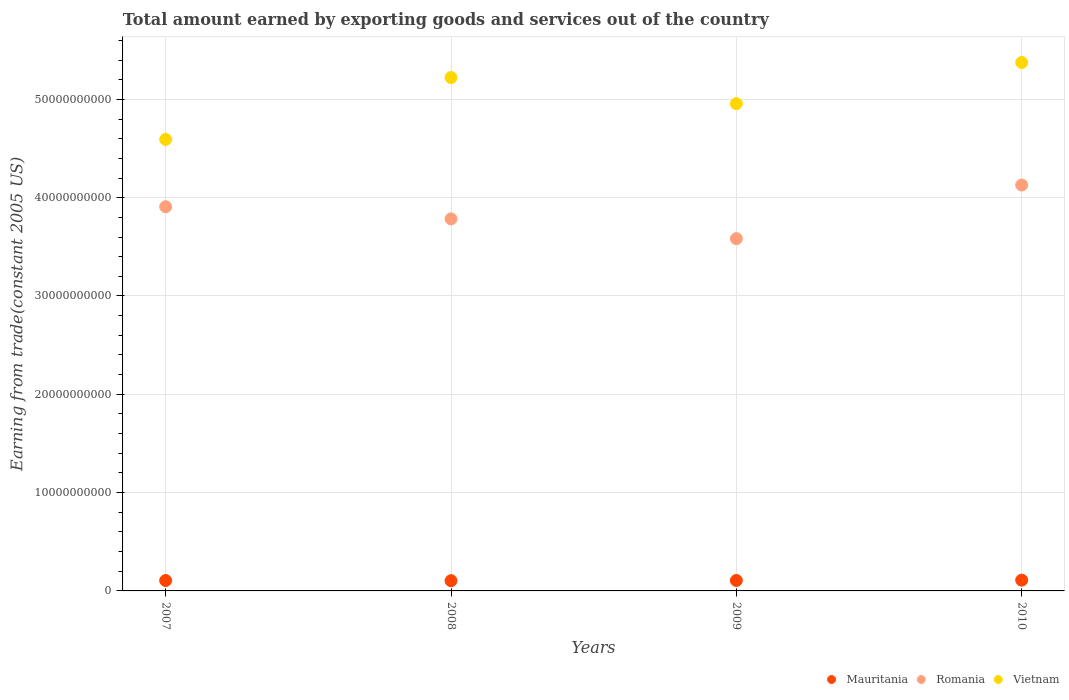Is the number of dotlines equal to the number of legend labels?
Your response must be concise. Yes. What is the total amount earned by exporting goods and services in Mauritania in 2008?
Provide a succinct answer. 1.04e+09. Across all years, what is the maximum total amount earned by exporting goods and services in Mauritania?
Your answer should be very brief. 1.10e+09. Across all years, what is the minimum total amount earned by exporting goods and services in Vietnam?
Your answer should be compact. 4.59e+1. In which year was the total amount earned by exporting goods and services in Mauritania maximum?
Offer a very short reply. 2010. What is the total total amount earned by exporting goods and services in Vietnam in the graph?
Give a very brief answer. 2.01e+11. What is the difference between the total amount earned by exporting goods and services in Mauritania in 2009 and that in 2010?
Your response must be concise. -3.44e+07. What is the difference between the total amount earned by exporting goods and services in Vietnam in 2009 and the total amount earned by exporting goods and services in Mauritania in 2007?
Give a very brief answer. 4.85e+1. What is the average total amount earned by exporting goods and services in Romania per year?
Your response must be concise. 3.85e+1. In the year 2007, what is the difference between the total amount earned by exporting goods and services in Mauritania and total amount earned by exporting goods and services in Vietnam?
Provide a short and direct response. -4.49e+1. What is the ratio of the total amount earned by exporting goods and services in Vietnam in 2007 to that in 2010?
Make the answer very short. 0.85. Is the difference between the total amount earned by exporting goods and services in Mauritania in 2008 and 2009 greater than the difference between the total amount earned by exporting goods and services in Vietnam in 2008 and 2009?
Provide a short and direct response. No. What is the difference between the highest and the second highest total amount earned by exporting goods and services in Mauritania?
Your answer should be very brief. 3.44e+07. What is the difference between the highest and the lowest total amount earned by exporting goods and services in Mauritania?
Keep it short and to the point. 5.71e+07. Is the sum of the total amount earned by exporting goods and services in Mauritania in 2008 and 2010 greater than the maximum total amount earned by exporting goods and services in Romania across all years?
Your response must be concise. No. Does the total amount earned by exporting goods and services in Romania monotonically increase over the years?
Ensure brevity in your answer.  No. Is the total amount earned by exporting goods and services in Vietnam strictly greater than the total amount earned by exporting goods and services in Mauritania over the years?
Provide a succinct answer. Yes. How many years are there in the graph?
Provide a short and direct response. 4. Where does the legend appear in the graph?
Your answer should be compact. Bottom right. How many legend labels are there?
Give a very brief answer. 3. What is the title of the graph?
Offer a terse response. Total amount earned by exporting goods and services out of the country. Does "Middle East & North Africa (all income levels)" appear as one of the legend labels in the graph?
Your response must be concise. No. What is the label or title of the X-axis?
Make the answer very short. Years. What is the label or title of the Y-axis?
Provide a succinct answer. Earning from trade(constant 2005 US). What is the Earning from trade(constant 2005 US) in Mauritania in 2007?
Ensure brevity in your answer.  1.06e+09. What is the Earning from trade(constant 2005 US) in Romania in 2007?
Your answer should be compact. 3.91e+1. What is the Earning from trade(constant 2005 US) in Vietnam in 2007?
Provide a short and direct response. 4.59e+1. What is the Earning from trade(constant 2005 US) in Mauritania in 2008?
Provide a short and direct response. 1.04e+09. What is the Earning from trade(constant 2005 US) of Romania in 2008?
Offer a terse response. 3.78e+1. What is the Earning from trade(constant 2005 US) of Vietnam in 2008?
Make the answer very short. 5.22e+1. What is the Earning from trade(constant 2005 US) of Mauritania in 2009?
Provide a short and direct response. 1.06e+09. What is the Earning from trade(constant 2005 US) in Romania in 2009?
Keep it short and to the point. 3.58e+1. What is the Earning from trade(constant 2005 US) in Vietnam in 2009?
Ensure brevity in your answer.  4.96e+1. What is the Earning from trade(constant 2005 US) of Mauritania in 2010?
Ensure brevity in your answer.  1.10e+09. What is the Earning from trade(constant 2005 US) of Romania in 2010?
Provide a short and direct response. 4.13e+1. What is the Earning from trade(constant 2005 US) of Vietnam in 2010?
Your answer should be compact. 5.38e+1. Across all years, what is the maximum Earning from trade(constant 2005 US) of Mauritania?
Keep it short and to the point. 1.10e+09. Across all years, what is the maximum Earning from trade(constant 2005 US) of Romania?
Your answer should be very brief. 4.13e+1. Across all years, what is the maximum Earning from trade(constant 2005 US) in Vietnam?
Keep it short and to the point. 5.38e+1. Across all years, what is the minimum Earning from trade(constant 2005 US) of Mauritania?
Offer a terse response. 1.04e+09. Across all years, what is the minimum Earning from trade(constant 2005 US) of Romania?
Ensure brevity in your answer.  3.58e+1. Across all years, what is the minimum Earning from trade(constant 2005 US) in Vietnam?
Make the answer very short. 4.59e+1. What is the total Earning from trade(constant 2005 US) of Mauritania in the graph?
Offer a terse response. 4.26e+09. What is the total Earning from trade(constant 2005 US) of Romania in the graph?
Offer a very short reply. 1.54e+11. What is the total Earning from trade(constant 2005 US) of Vietnam in the graph?
Keep it short and to the point. 2.01e+11. What is the difference between the Earning from trade(constant 2005 US) in Mauritania in 2007 and that in 2008?
Make the answer very short. 1.81e+07. What is the difference between the Earning from trade(constant 2005 US) in Romania in 2007 and that in 2008?
Make the answer very short. 1.23e+09. What is the difference between the Earning from trade(constant 2005 US) of Vietnam in 2007 and that in 2008?
Give a very brief answer. -6.29e+09. What is the difference between the Earning from trade(constant 2005 US) of Mauritania in 2007 and that in 2009?
Ensure brevity in your answer.  -4.60e+06. What is the difference between the Earning from trade(constant 2005 US) in Romania in 2007 and that in 2009?
Your answer should be very brief. 3.25e+09. What is the difference between the Earning from trade(constant 2005 US) in Vietnam in 2007 and that in 2009?
Your response must be concise. -3.64e+09. What is the difference between the Earning from trade(constant 2005 US) in Mauritania in 2007 and that in 2010?
Offer a terse response. -3.90e+07. What is the difference between the Earning from trade(constant 2005 US) in Romania in 2007 and that in 2010?
Make the answer very short. -2.21e+09. What is the difference between the Earning from trade(constant 2005 US) of Vietnam in 2007 and that in 2010?
Provide a short and direct response. -7.82e+09. What is the difference between the Earning from trade(constant 2005 US) in Mauritania in 2008 and that in 2009?
Provide a short and direct response. -2.27e+07. What is the difference between the Earning from trade(constant 2005 US) of Romania in 2008 and that in 2009?
Provide a short and direct response. 2.01e+09. What is the difference between the Earning from trade(constant 2005 US) of Vietnam in 2008 and that in 2009?
Offer a very short reply. 2.66e+09. What is the difference between the Earning from trade(constant 2005 US) in Mauritania in 2008 and that in 2010?
Provide a succinct answer. -5.71e+07. What is the difference between the Earning from trade(constant 2005 US) in Romania in 2008 and that in 2010?
Provide a short and direct response. -3.44e+09. What is the difference between the Earning from trade(constant 2005 US) in Vietnam in 2008 and that in 2010?
Keep it short and to the point. -1.53e+09. What is the difference between the Earning from trade(constant 2005 US) of Mauritania in 2009 and that in 2010?
Offer a terse response. -3.44e+07. What is the difference between the Earning from trade(constant 2005 US) of Romania in 2009 and that in 2010?
Offer a very short reply. -5.46e+09. What is the difference between the Earning from trade(constant 2005 US) of Vietnam in 2009 and that in 2010?
Your response must be concise. -4.19e+09. What is the difference between the Earning from trade(constant 2005 US) of Mauritania in 2007 and the Earning from trade(constant 2005 US) of Romania in 2008?
Make the answer very short. -3.68e+1. What is the difference between the Earning from trade(constant 2005 US) in Mauritania in 2007 and the Earning from trade(constant 2005 US) in Vietnam in 2008?
Offer a terse response. -5.12e+1. What is the difference between the Earning from trade(constant 2005 US) of Romania in 2007 and the Earning from trade(constant 2005 US) of Vietnam in 2008?
Provide a succinct answer. -1.31e+1. What is the difference between the Earning from trade(constant 2005 US) of Mauritania in 2007 and the Earning from trade(constant 2005 US) of Romania in 2009?
Offer a very short reply. -3.48e+1. What is the difference between the Earning from trade(constant 2005 US) in Mauritania in 2007 and the Earning from trade(constant 2005 US) in Vietnam in 2009?
Your response must be concise. -4.85e+1. What is the difference between the Earning from trade(constant 2005 US) of Romania in 2007 and the Earning from trade(constant 2005 US) of Vietnam in 2009?
Your response must be concise. -1.05e+1. What is the difference between the Earning from trade(constant 2005 US) in Mauritania in 2007 and the Earning from trade(constant 2005 US) in Romania in 2010?
Make the answer very short. -4.02e+1. What is the difference between the Earning from trade(constant 2005 US) of Mauritania in 2007 and the Earning from trade(constant 2005 US) of Vietnam in 2010?
Your answer should be compact. -5.27e+1. What is the difference between the Earning from trade(constant 2005 US) in Romania in 2007 and the Earning from trade(constant 2005 US) in Vietnam in 2010?
Offer a very short reply. -1.47e+1. What is the difference between the Earning from trade(constant 2005 US) of Mauritania in 2008 and the Earning from trade(constant 2005 US) of Romania in 2009?
Offer a very short reply. -3.48e+1. What is the difference between the Earning from trade(constant 2005 US) in Mauritania in 2008 and the Earning from trade(constant 2005 US) in Vietnam in 2009?
Offer a very short reply. -4.85e+1. What is the difference between the Earning from trade(constant 2005 US) of Romania in 2008 and the Earning from trade(constant 2005 US) of Vietnam in 2009?
Provide a succinct answer. -1.17e+1. What is the difference between the Earning from trade(constant 2005 US) of Mauritania in 2008 and the Earning from trade(constant 2005 US) of Romania in 2010?
Offer a terse response. -4.02e+1. What is the difference between the Earning from trade(constant 2005 US) of Mauritania in 2008 and the Earning from trade(constant 2005 US) of Vietnam in 2010?
Keep it short and to the point. -5.27e+1. What is the difference between the Earning from trade(constant 2005 US) of Romania in 2008 and the Earning from trade(constant 2005 US) of Vietnam in 2010?
Give a very brief answer. -1.59e+1. What is the difference between the Earning from trade(constant 2005 US) in Mauritania in 2009 and the Earning from trade(constant 2005 US) in Romania in 2010?
Make the answer very short. -4.02e+1. What is the difference between the Earning from trade(constant 2005 US) in Mauritania in 2009 and the Earning from trade(constant 2005 US) in Vietnam in 2010?
Your response must be concise. -5.27e+1. What is the difference between the Earning from trade(constant 2005 US) of Romania in 2009 and the Earning from trade(constant 2005 US) of Vietnam in 2010?
Make the answer very short. -1.79e+1. What is the average Earning from trade(constant 2005 US) of Mauritania per year?
Your answer should be compact. 1.06e+09. What is the average Earning from trade(constant 2005 US) of Romania per year?
Your answer should be very brief. 3.85e+1. What is the average Earning from trade(constant 2005 US) of Vietnam per year?
Your response must be concise. 5.04e+1. In the year 2007, what is the difference between the Earning from trade(constant 2005 US) of Mauritania and Earning from trade(constant 2005 US) of Romania?
Offer a very short reply. -3.80e+1. In the year 2007, what is the difference between the Earning from trade(constant 2005 US) of Mauritania and Earning from trade(constant 2005 US) of Vietnam?
Your answer should be compact. -4.49e+1. In the year 2007, what is the difference between the Earning from trade(constant 2005 US) of Romania and Earning from trade(constant 2005 US) of Vietnam?
Provide a short and direct response. -6.85e+09. In the year 2008, what is the difference between the Earning from trade(constant 2005 US) in Mauritania and Earning from trade(constant 2005 US) in Romania?
Your answer should be compact. -3.68e+1. In the year 2008, what is the difference between the Earning from trade(constant 2005 US) of Mauritania and Earning from trade(constant 2005 US) of Vietnam?
Offer a terse response. -5.12e+1. In the year 2008, what is the difference between the Earning from trade(constant 2005 US) in Romania and Earning from trade(constant 2005 US) in Vietnam?
Make the answer very short. -1.44e+1. In the year 2009, what is the difference between the Earning from trade(constant 2005 US) in Mauritania and Earning from trade(constant 2005 US) in Romania?
Provide a short and direct response. -3.48e+1. In the year 2009, what is the difference between the Earning from trade(constant 2005 US) of Mauritania and Earning from trade(constant 2005 US) of Vietnam?
Your answer should be compact. -4.85e+1. In the year 2009, what is the difference between the Earning from trade(constant 2005 US) of Romania and Earning from trade(constant 2005 US) of Vietnam?
Your response must be concise. -1.37e+1. In the year 2010, what is the difference between the Earning from trade(constant 2005 US) in Mauritania and Earning from trade(constant 2005 US) in Romania?
Make the answer very short. -4.02e+1. In the year 2010, what is the difference between the Earning from trade(constant 2005 US) in Mauritania and Earning from trade(constant 2005 US) in Vietnam?
Your answer should be compact. -5.27e+1. In the year 2010, what is the difference between the Earning from trade(constant 2005 US) in Romania and Earning from trade(constant 2005 US) in Vietnam?
Ensure brevity in your answer.  -1.25e+1. What is the ratio of the Earning from trade(constant 2005 US) in Mauritania in 2007 to that in 2008?
Offer a very short reply. 1.02. What is the ratio of the Earning from trade(constant 2005 US) of Romania in 2007 to that in 2008?
Ensure brevity in your answer.  1.03. What is the ratio of the Earning from trade(constant 2005 US) in Vietnam in 2007 to that in 2008?
Your answer should be compact. 0.88. What is the ratio of the Earning from trade(constant 2005 US) of Mauritania in 2007 to that in 2009?
Provide a short and direct response. 1. What is the ratio of the Earning from trade(constant 2005 US) in Romania in 2007 to that in 2009?
Make the answer very short. 1.09. What is the ratio of the Earning from trade(constant 2005 US) in Vietnam in 2007 to that in 2009?
Offer a terse response. 0.93. What is the ratio of the Earning from trade(constant 2005 US) in Mauritania in 2007 to that in 2010?
Provide a succinct answer. 0.96. What is the ratio of the Earning from trade(constant 2005 US) of Romania in 2007 to that in 2010?
Provide a short and direct response. 0.95. What is the ratio of the Earning from trade(constant 2005 US) of Vietnam in 2007 to that in 2010?
Make the answer very short. 0.85. What is the ratio of the Earning from trade(constant 2005 US) in Mauritania in 2008 to that in 2009?
Give a very brief answer. 0.98. What is the ratio of the Earning from trade(constant 2005 US) of Romania in 2008 to that in 2009?
Offer a terse response. 1.06. What is the ratio of the Earning from trade(constant 2005 US) of Vietnam in 2008 to that in 2009?
Keep it short and to the point. 1.05. What is the ratio of the Earning from trade(constant 2005 US) of Mauritania in 2008 to that in 2010?
Make the answer very short. 0.95. What is the ratio of the Earning from trade(constant 2005 US) in Romania in 2008 to that in 2010?
Keep it short and to the point. 0.92. What is the ratio of the Earning from trade(constant 2005 US) in Vietnam in 2008 to that in 2010?
Your response must be concise. 0.97. What is the ratio of the Earning from trade(constant 2005 US) of Mauritania in 2009 to that in 2010?
Your answer should be compact. 0.97. What is the ratio of the Earning from trade(constant 2005 US) in Romania in 2009 to that in 2010?
Provide a short and direct response. 0.87. What is the ratio of the Earning from trade(constant 2005 US) in Vietnam in 2009 to that in 2010?
Keep it short and to the point. 0.92. What is the difference between the highest and the second highest Earning from trade(constant 2005 US) of Mauritania?
Ensure brevity in your answer.  3.44e+07. What is the difference between the highest and the second highest Earning from trade(constant 2005 US) in Romania?
Offer a very short reply. 2.21e+09. What is the difference between the highest and the second highest Earning from trade(constant 2005 US) of Vietnam?
Give a very brief answer. 1.53e+09. What is the difference between the highest and the lowest Earning from trade(constant 2005 US) in Mauritania?
Your answer should be compact. 5.71e+07. What is the difference between the highest and the lowest Earning from trade(constant 2005 US) of Romania?
Make the answer very short. 5.46e+09. What is the difference between the highest and the lowest Earning from trade(constant 2005 US) in Vietnam?
Ensure brevity in your answer.  7.82e+09. 